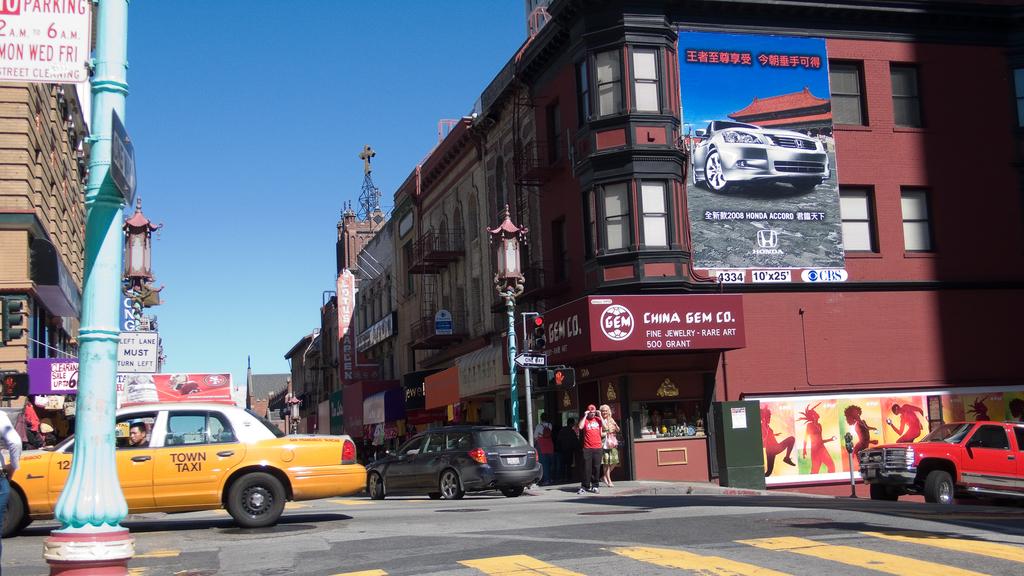What store name is on the awning at the end on the right side?
Make the answer very short. China gem co. 